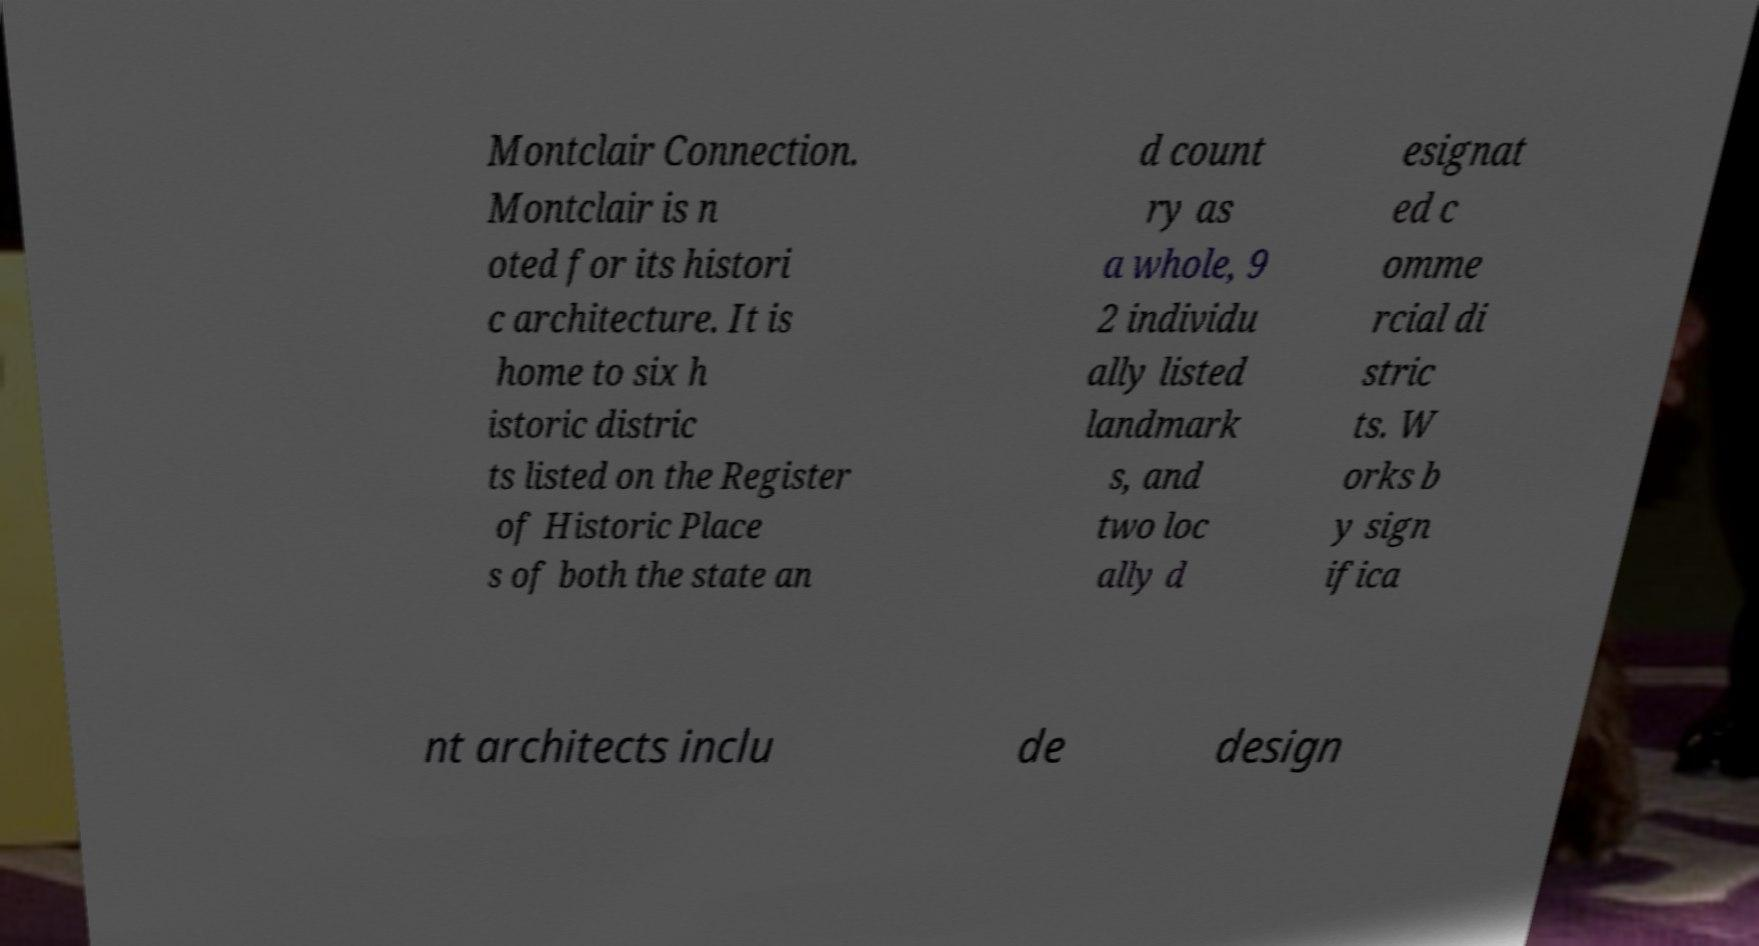Please read and relay the text visible in this image. What does it say? Montclair Connection. Montclair is n oted for its histori c architecture. It is home to six h istoric distric ts listed on the Register of Historic Place s of both the state an d count ry as a whole, 9 2 individu ally listed landmark s, and two loc ally d esignat ed c omme rcial di stric ts. W orks b y sign ifica nt architects inclu de design 